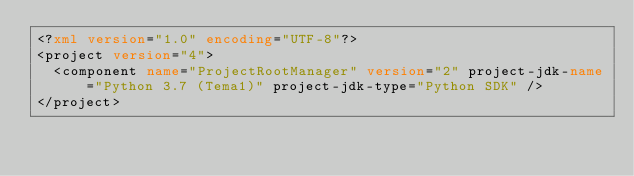Convert code to text. <code><loc_0><loc_0><loc_500><loc_500><_XML_><?xml version="1.0" encoding="UTF-8"?>
<project version="4">
  <component name="ProjectRootManager" version="2" project-jdk-name="Python 3.7 (Tema1)" project-jdk-type="Python SDK" />
</project></code> 